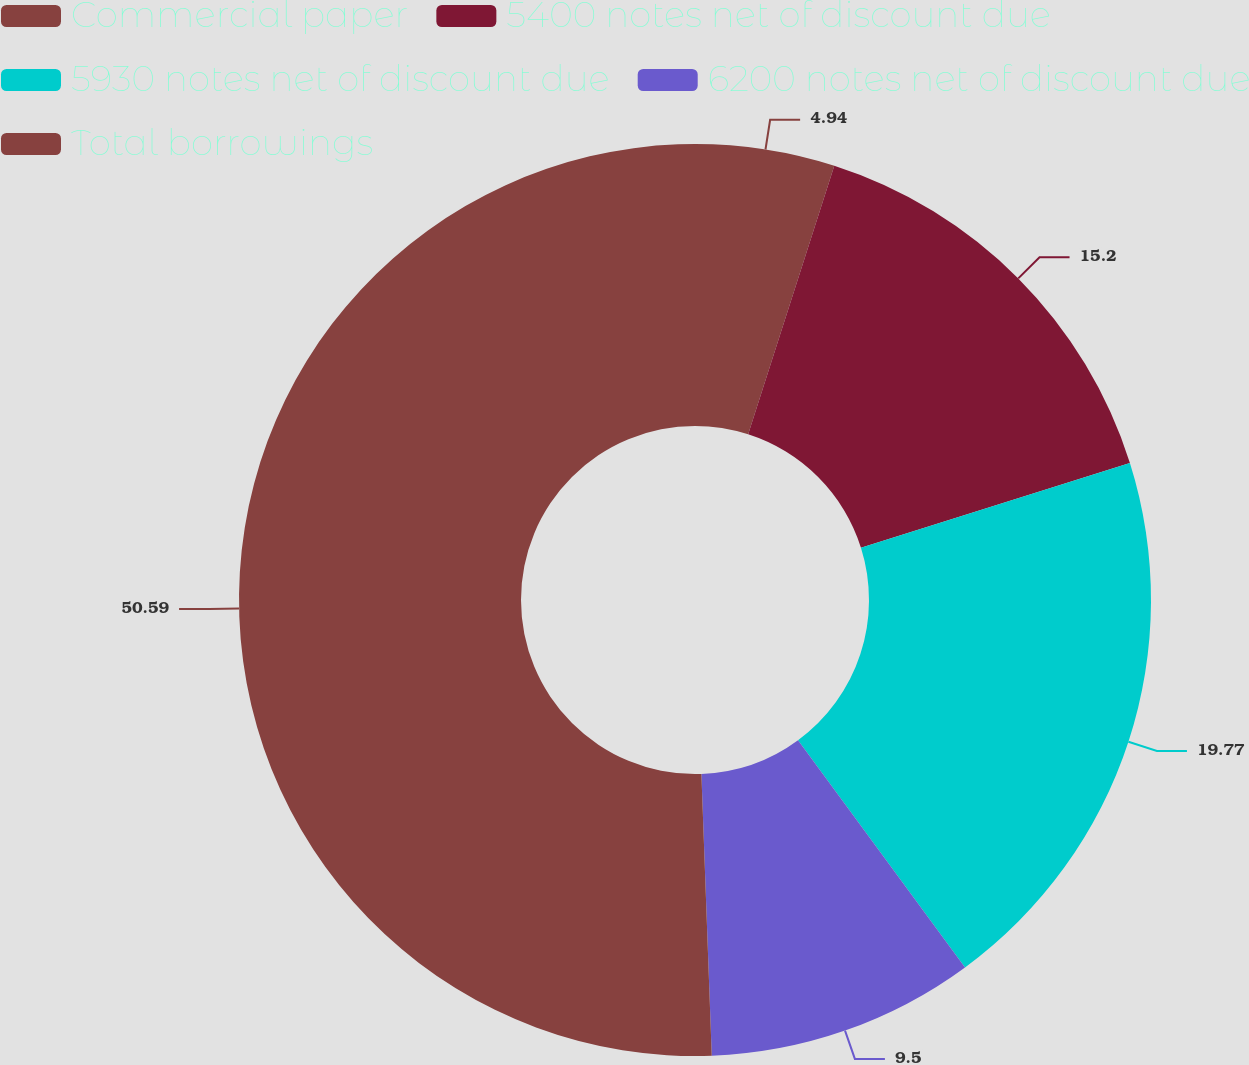<chart> <loc_0><loc_0><loc_500><loc_500><pie_chart><fcel>Commercial paper<fcel>5400 notes net of discount due<fcel>5930 notes net of discount due<fcel>6200 notes net of discount due<fcel>Total borrowings<nl><fcel>4.94%<fcel>15.2%<fcel>19.77%<fcel>9.5%<fcel>50.58%<nl></chart> 